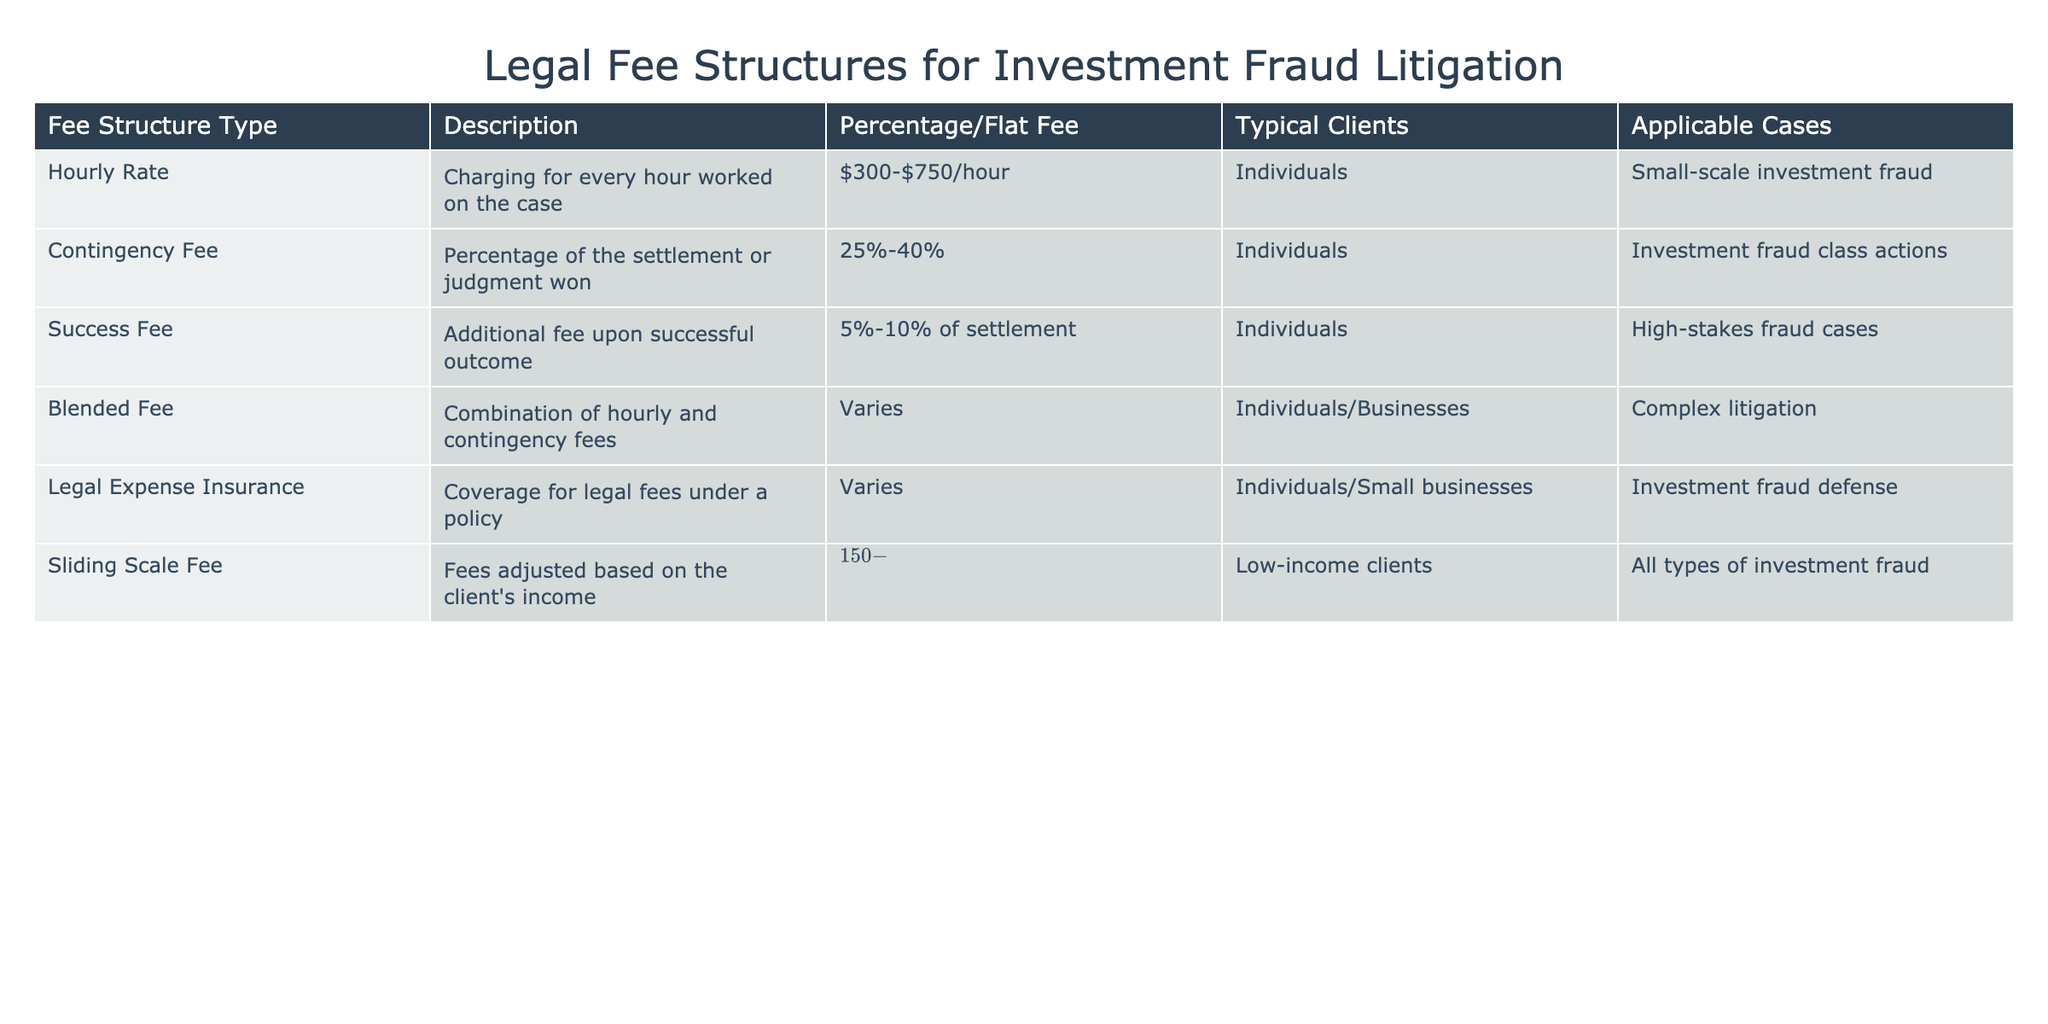What is the percentage range for the contingency fee structure? The table states that the contingency fee takes a percentage of the settlement or judgment won and specifies that this percentage range is 25%-40%.
Answer: 25%-40% Which fee structure is designed for low-income clients? The sliding scale fee structure is specifically tailored for low-income clients, allowing fees to be adjusted based on their income.
Answer: Sliding scale fee What is the typical fee charged for an hourly rate? According to the table, the typical charge for an hourly rate is between $300 and $750 per hour.
Answer: $300-$750/hour Is there a fee structure that applies to both individuals and businesses? Yes, the blended fee structure applies to both individuals and businesses, as mentioned in the table.
Answer: Yes If a settlement amount is $1,000,000, what could be the success fee amount? The success fee is based on a percentage of the settlement, which is stated as 5%-10%. Therefore, the success fee could range from 5% of $1,000,000, which is $50,000, to 10% of $1,000,000, which is $100,000.
Answer: $50,000-$100,000 What is the typical client type for legal expense insurance? The typical clients for legal expense insurance are individuals and small businesses, as described in the table.
Answer: Individuals/Small businesses How many fee structures are specifically applicable to investment fraud class actions? The table shows that there are two fee structures applicable to investment fraud class actions: contingency fee and sliding scale fee. Thus, the answer is two.
Answer: Two What is the combined percentage of fees for a situation with a sliding scale fee and a success fee, if the sliding scale fee is $300/hour and the success fee is 10% of a settlement? The sliding scale fee does not directly translate to a percentage, as it's based on hourly rates, while the success fee is a fixed percentage of the settlement. One cannot sum these directly since they apply in different contexts; hence, it's impossible to provide a single combined percentage.
Answer: Not applicable How do the fees of the sliding scale compare to hourly rates? The sliding scale fees range from $150 to $400 per hour, while hourly rates range from $300 to $750 per hour, meaning sliding scale fees can be lower than standard hourly rates by up to $150.
Answer: Sliding scale fees are lower 